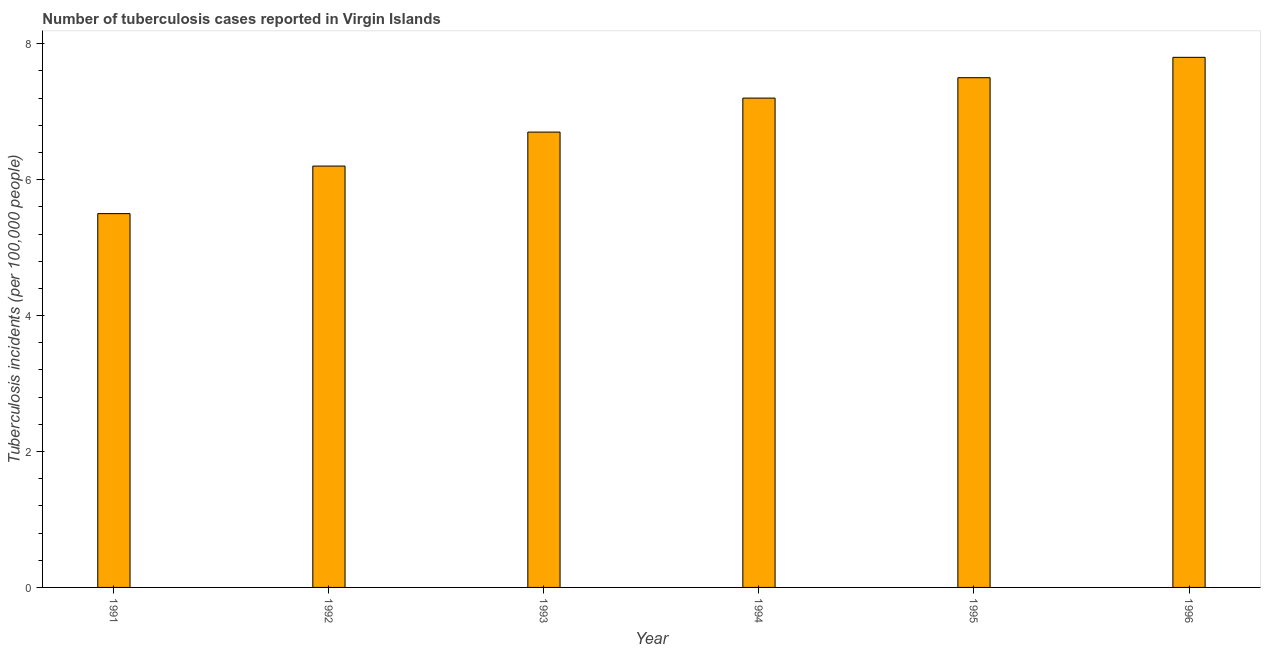Does the graph contain grids?
Keep it short and to the point. No. What is the title of the graph?
Keep it short and to the point. Number of tuberculosis cases reported in Virgin Islands. What is the label or title of the X-axis?
Make the answer very short. Year. What is the label or title of the Y-axis?
Give a very brief answer. Tuberculosis incidents (per 100,0 people). In which year was the number of tuberculosis incidents maximum?
Provide a succinct answer. 1996. In which year was the number of tuberculosis incidents minimum?
Your answer should be compact. 1991. What is the sum of the number of tuberculosis incidents?
Make the answer very short. 40.9. What is the average number of tuberculosis incidents per year?
Give a very brief answer. 6.82. What is the median number of tuberculosis incidents?
Give a very brief answer. 6.95. In how many years, is the number of tuberculosis incidents greater than 1.6 ?
Keep it short and to the point. 6. What is the ratio of the number of tuberculosis incidents in 1991 to that in 1996?
Keep it short and to the point. 0.7. Is the difference between the number of tuberculosis incidents in 1992 and 1993 greater than the difference between any two years?
Give a very brief answer. No. What is the difference between the highest and the second highest number of tuberculosis incidents?
Offer a very short reply. 0.3. Is the sum of the number of tuberculosis incidents in 1992 and 1994 greater than the maximum number of tuberculosis incidents across all years?
Your answer should be compact. Yes. What is the difference between the highest and the lowest number of tuberculosis incidents?
Offer a terse response. 2.3. In how many years, is the number of tuberculosis incidents greater than the average number of tuberculosis incidents taken over all years?
Your answer should be compact. 3. What is the Tuberculosis incidents (per 100,000 people) in 1991?
Keep it short and to the point. 5.5. What is the Tuberculosis incidents (per 100,000 people) of 1994?
Ensure brevity in your answer.  7.2. What is the Tuberculosis incidents (per 100,000 people) of 1996?
Provide a succinct answer. 7.8. What is the difference between the Tuberculosis incidents (per 100,000 people) in 1991 and 1992?
Make the answer very short. -0.7. What is the difference between the Tuberculosis incidents (per 100,000 people) in 1991 and 1994?
Your answer should be very brief. -1.7. What is the difference between the Tuberculosis incidents (per 100,000 people) in 1992 and 1993?
Provide a succinct answer. -0.5. What is the difference between the Tuberculosis incidents (per 100,000 people) in 1992 and 1994?
Your response must be concise. -1. What is the difference between the Tuberculosis incidents (per 100,000 people) in 1992 and 1995?
Give a very brief answer. -1.3. What is the difference between the Tuberculosis incidents (per 100,000 people) in 1992 and 1996?
Give a very brief answer. -1.6. What is the difference between the Tuberculosis incidents (per 100,000 people) in 1993 and 1996?
Your response must be concise. -1.1. What is the difference between the Tuberculosis incidents (per 100,000 people) in 1994 and 1995?
Offer a very short reply. -0.3. What is the ratio of the Tuberculosis incidents (per 100,000 people) in 1991 to that in 1992?
Provide a succinct answer. 0.89. What is the ratio of the Tuberculosis incidents (per 100,000 people) in 1991 to that in 1993?
Ensure brevity in your answer.  0.82. What is the ratio of the Tuberculosis incidents (per 100,000 people) in 1991 to that in 1994?
Provide a short and direct response. 0.76. What is the ratio of the Tuberculosis incidents (per 100,000 people) in 1991 to that in 1995?
Keep it short and to the point. 0.73. What is the ratio of the Tuberculosis incidents (per 100,000 people) in 1991 to that in 1996?
Your answer should be compact. 0.7. What is the ratio of the Tuberculosis incidents (per 100,000 people) in 1992 to that in 1993?
Make the answer very short. 0.93. What is the ratio of the Tuberculosis incidents (per 100,000 people) in 1992 to that in 1994?
Ensure brevity in your answer.  0.86. What is the ratio of the Tuberculosis incidents (per 100,000 people) in 1992 to that in 1995?
Your answer should be very brief. 0.83. What is the ratio of the Tuberculosis incidents (per 100,000 people) in 1992 to that in 1996?
Offer a very short reply. 0.8. What is the ratio of the Tuberculosis incidents (per 100,000 people) in 1993 to that in 1995?
Offer a very short reply. 0.89. What is the ratio of the Tuberculosis incidents (per 100,000 people) in 1993 to that in 1996?
Make the answer very short. 0.86. What is the ratio of the Tuberculosis incidents (per 100,000 people) in 1994 to that in 1996?
Your answer should be very brief. 0.92. What is the ratio of the Tuberculosis incidents (per 100,000 people) in 1995 to that in 1996?
Your answer should be compact. 0.96. 